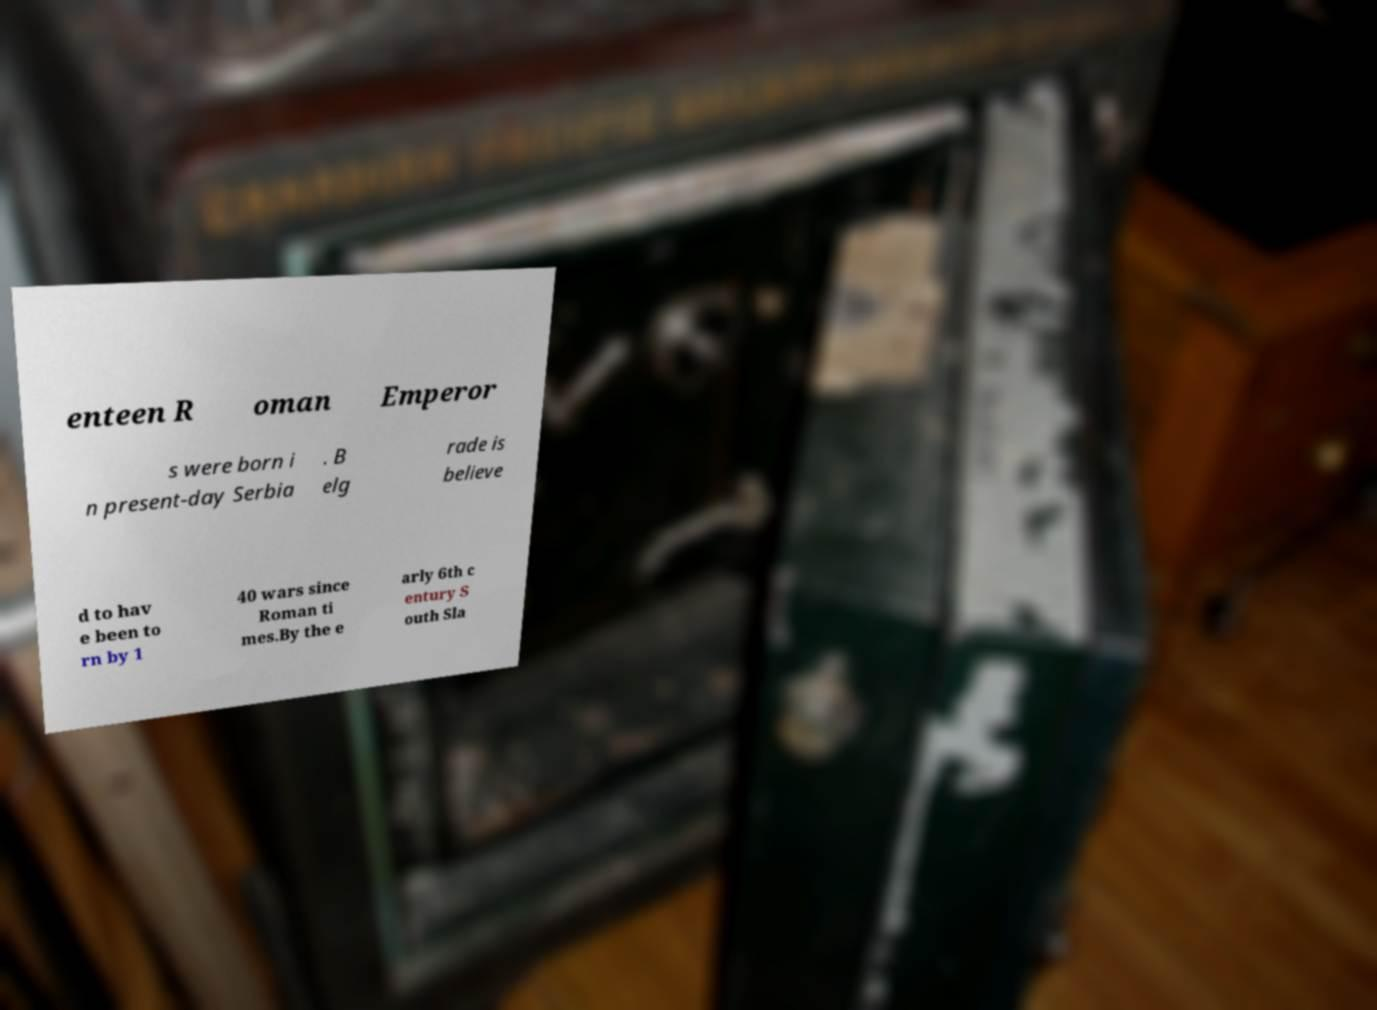Please identify and transcribe the text found in this image. enteen R oman Emperor s were born i n present-day Serbia . B elg rade is believe d to hav e been to rn by 1 40 wars since Roman ti mes.By the e arly 6th c entury S outh Sla 